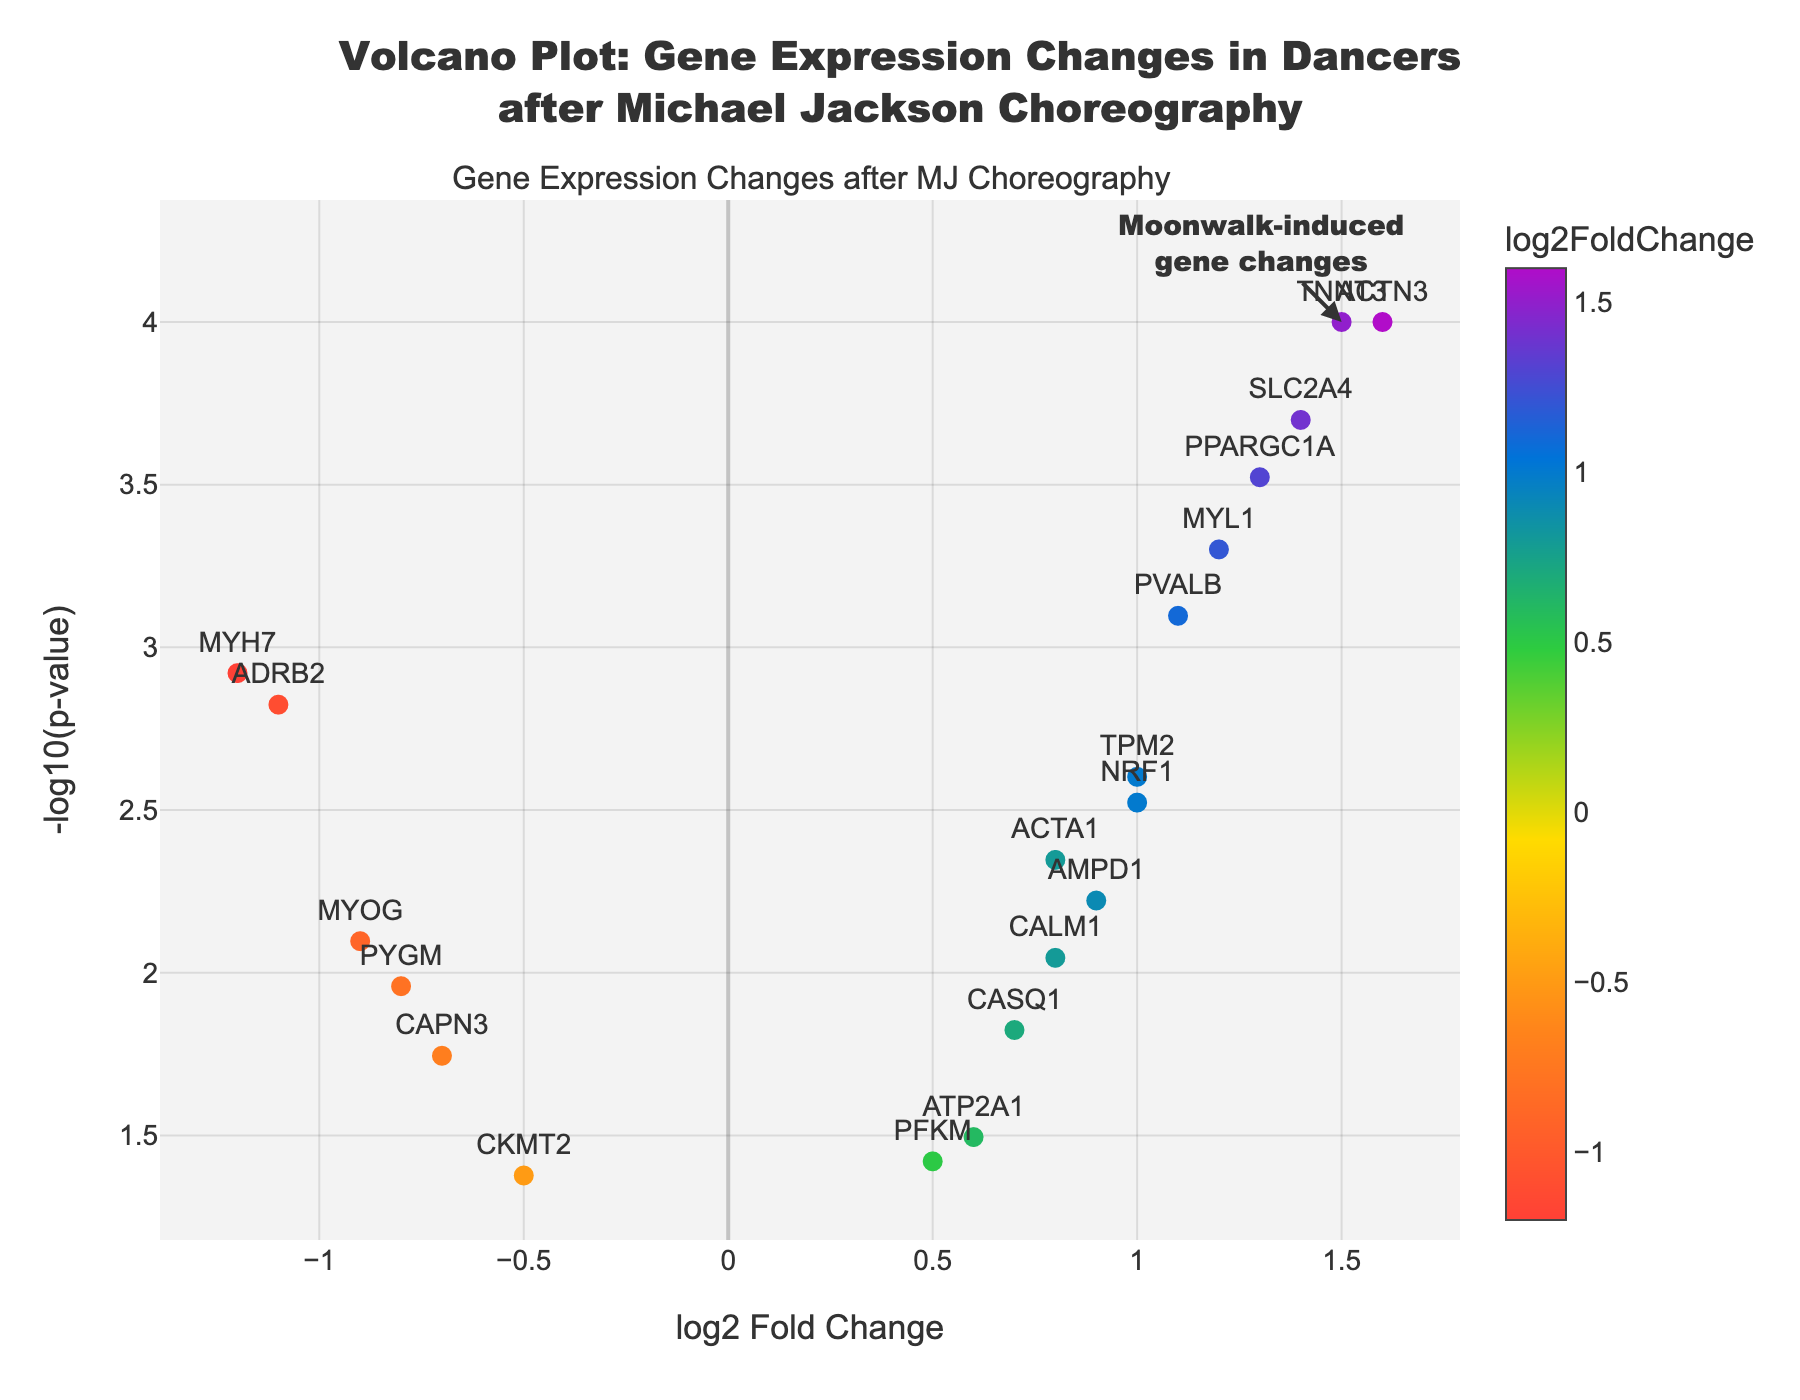What is the title of the figure? The title is usually found at the top of the figure and serves as a summary description of what the figure represents. In this case, it describes gene expression changes after performing Michael Jackson choreography.
Answer: Volcano Plot: Gene Expression Changes in Dancers after Michael Jackson Choreography What are the x and y axes representing? The x-axis often indicates a specific measurement or category, while the y-axis represents another measurement. In a volcano plot, the x-axis represents log2 Fold Change, and the y-axis represents -log10(p-value).
Answer: x-axis: log2 Fold Change, y-axis: -log10(p-value) How many genes have a log2 Fold Change greater than 1.0? To determine the number of genes with a log2 Fold Change greater than 1.0, we count all points on the figure that are located to the right of the 1.0 mark on the x-axis. By examining the plot's data, there are 5 such genes: TNNT3, PPARGC1A, SLC2A4, ACTN3, MYL1.
Answer: 5 Which gene shows the highest log2 Fold Change? To find the gene with the highest log2 Fold Change, we look for the data point furthest to the right on the x-axis. The gene ACTN3 has the highest log2 Fold Change, displayed clearly on the plot.
Answer: ACTN3 What is the p-value for the gene with the most significant change? The p-value can be found by looking at the y-axis, which represents -log10(p-value). Higher points on the y-axis indicate more significant p-values. The gene with the highest value on the y-axis is TNNT3, with a p-value of 0.0001.
Answer: 0.0001 Which gene has the lowest log2 Fold Change? To find the gene with the lowest log2 Fold Change, we examine the point furthest to the left on the x-axis. The gene with the lowest log2 Fold Change is MYH7, with a value of -1.2.
Answer: MYH7 Compare the log2 Fold Change of PVALB and MYOG. Which is higher? We need to look at the positions of PVALB and MYOG on the x-axis and compare their values. PVALB has a log2 Fold Change of 1.1, and MYOG has -0.9. Since 1.1 is greater than -0.9, PVALB has a higher log2 Fold Change than MYOG.
Answer: PVALB What is the significance threshold for p-values, and how many genes are below this threshold? To identify genes below a significance threshold, we check their positions on the y-axis. Generally, a common significance threshold is 0.05 (equivalent to -log10(0.05) ≈ 1.3). There are 5 genes with -log10(p-value) higher than 1.3 (below 0.05 p-value): TNNT3, PVALB, PPARGC1A, MYL1, SLC2A4.
Answer: 5 Which gene has the closest log2 Fold Change to zero but is still statistically significant? To find the gene with a log2 Fold Change closest to zero, we look for the point nearest the y-axis center (log2 Fold Change of 0) and ensure it is above the significance threshold. The gene ATP2A1 with a log2 Fold Change of 0.6 and a p-value of 0.0320 fits this description.
Answer: ATP2A1 How can one visually identify significant gene changes induced by Michael Jackson choreography in the plot? Significant gene changes are usually represented by points that are farthest from the origin along the y-axis, indicating low p-values. These points are often annotated or highlighted. In this plot, the annotation points to significant changes caused by "Moonwalk-induced gene changes" near the top-right corner, highlighting significant genes like TNNT3 and ACTN3.
Answer: Points farthest from the origin along the y-axis 